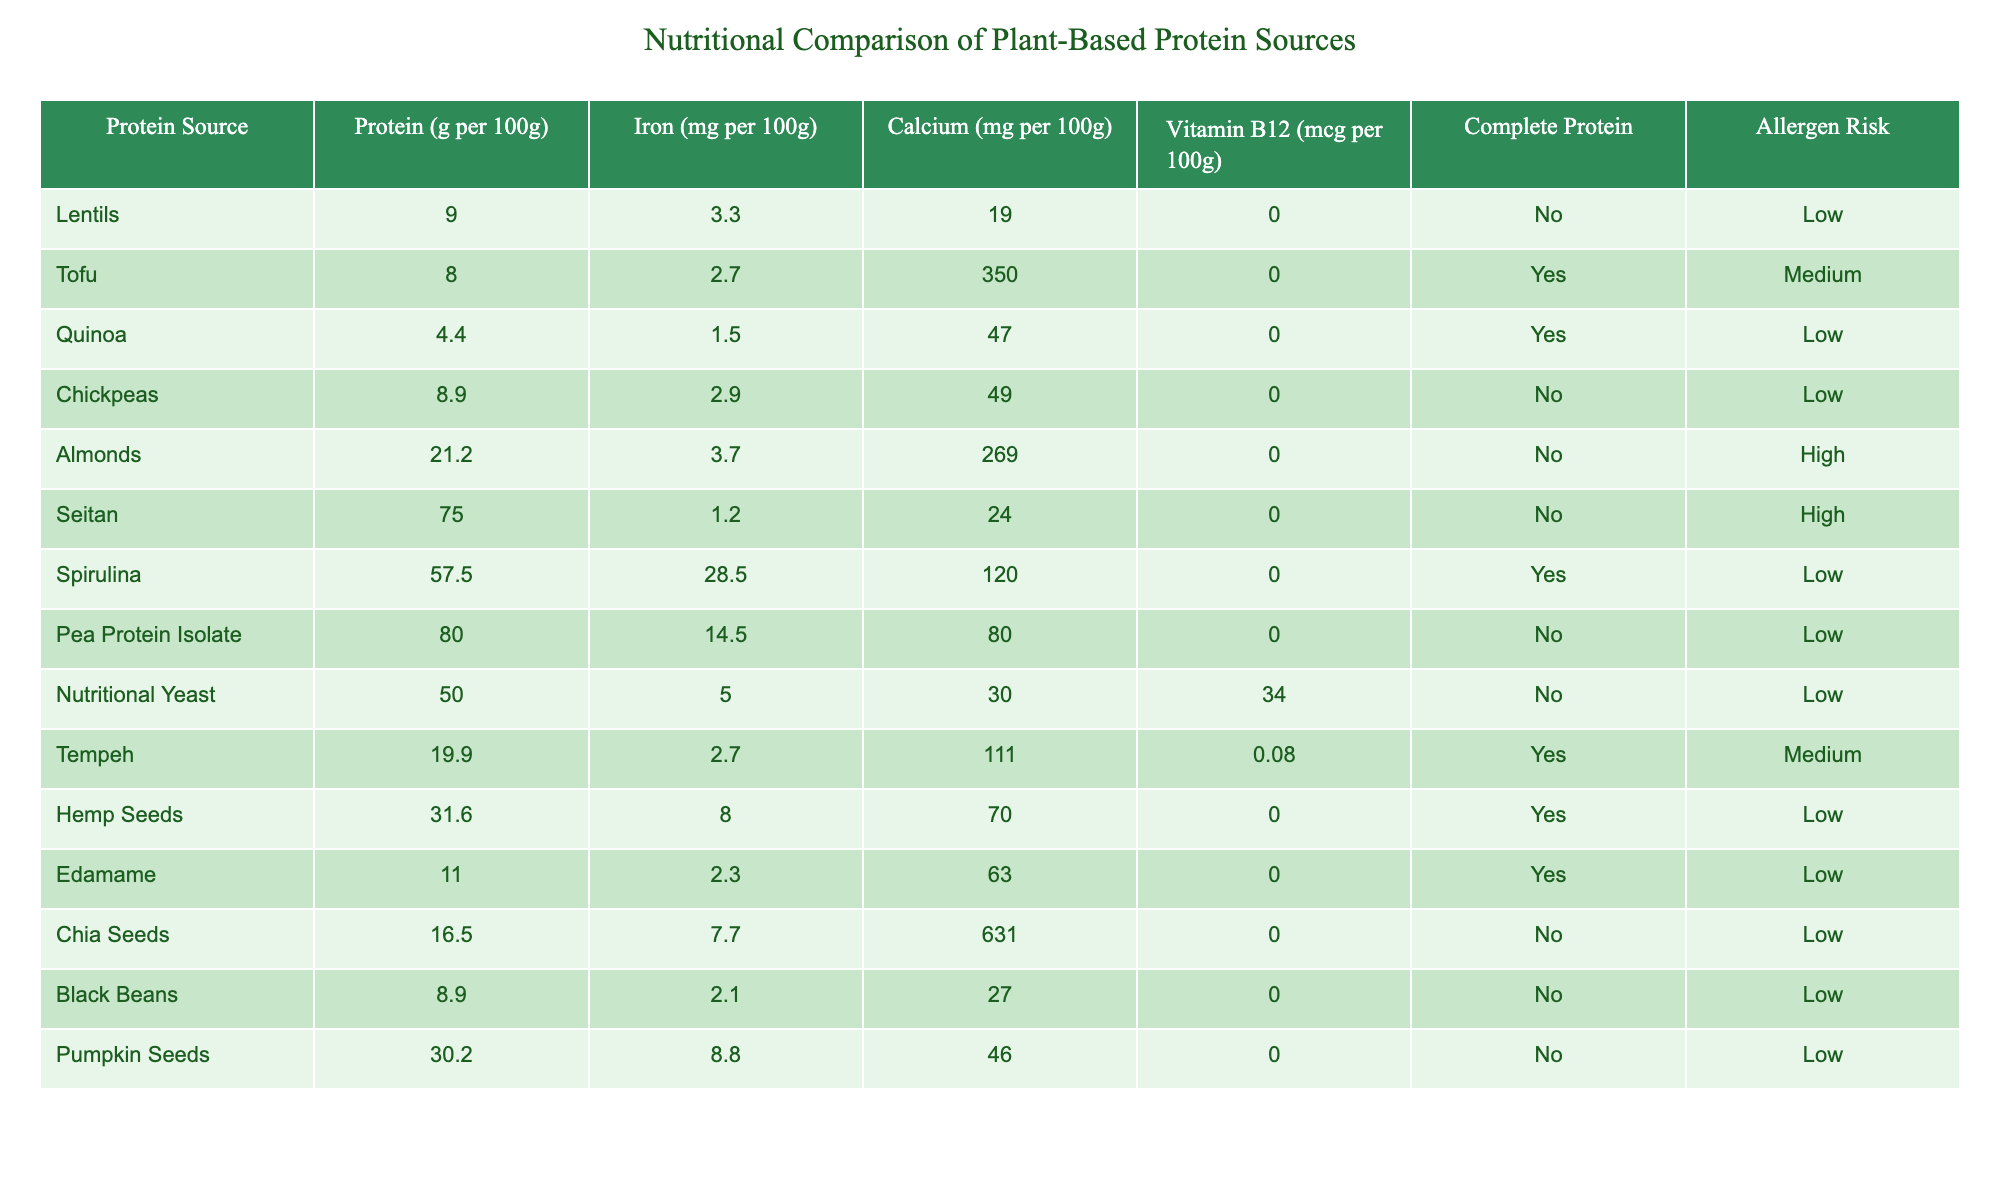What is the protein content in almonds? The table shows that almonds have a protein content of 21.2 grams per 100 grams.
Answer: 21.2 grams Which protein source has the highest iron content? By comparing the iron content listed for all protein sources, spirulina has the highest iron content at 28.5 mg per 100 grams.
Answer: Spirulina Do any of the protein sources provide Vitamin B12? The table indicates that only nutritional yeast provides Vitamin B12, with a content of 34 mcg per 100 grams.
Answer: Yes How much calcium is found in tempeh? According to the table, tempeh contains 111 mg of calcium per 100 grams.
Answer: 111 mg What is the average protein content of the protein sources listed? To find the average protein content, sum the protein values and divide by the number of sources: (9 + 8 + 4.4 + 8.9 + 21.2 + 75 + 57.5 + 80 + 50 + 19.9 + 31.6 + 11 + 16.5 + 8.9 + 30.2) which equals  392.6 grams. Dividing by 15 sources gives approximately 26.1 grams.
Answer: 26.1 grams Which protein sources are considered complete proteins? By examining the "Complete Protein" column, tofu, quinoa, spirulina, tempeh, and hemp seeds are the sources identified as complete proteins.
Answer: Tofu, Quinoa, Spirulina, Tempeh, Hemp Seeds What is the allergen risk level of chickpeas? The table states that chickpeas have a low allergen risk level.
Answer: Low How does the protein content of seitan compare to that of pea protein isolate? Seitan has 75 grams of protein per 100 grams, while pea protein isolate has 80 grams. Pea protein isolate has more protein than seitan.
Answer: Pea protein isolate has more protein Is there a source of plant-based protein that contains calcium but no Vitamin B12? Referring to the table, both tofu and tempeh contain calcium (350 mg and 111 mg, respectively) but do not provide Vitamin B12.
Answer: Yes, Tofu and Tempeh What is the difference in protein content between spirulina and lentils? Spirulina contains 57.5 grams per 100 grams while lentils contain 9.0 grams. The difference is 57.5 - 9.0 = 48.5 grams.
Answer: 48.5 grams 